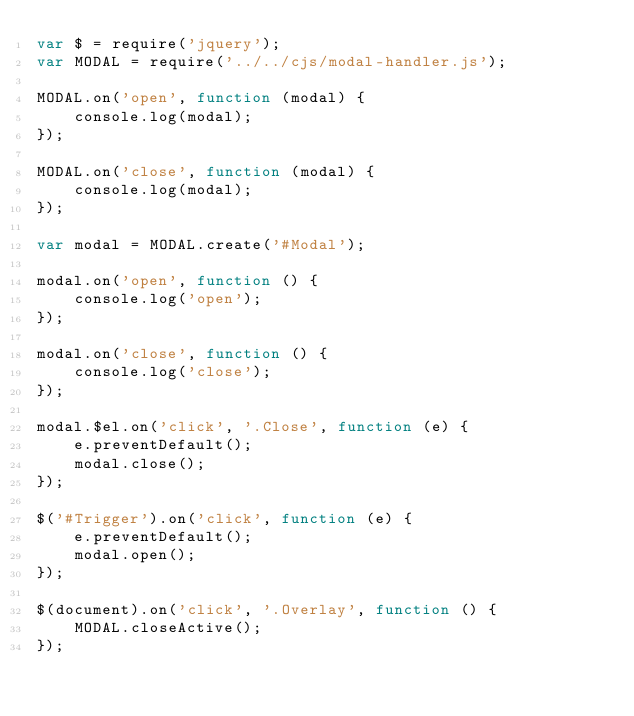<code> <loc_0><loc_0><loc_500><loc_500><_JavaScript_>var $ = require('jquery');
var MODAL = require('../../cjs/modal-handler.js');

MODAL.on('open', function (modal) {
    console.log(modal);
});

MODAL.on('close', function (modal) {
    console.log(modal);
});

var modal = MODAL.create('#Modal');

modal.on('open', function () {
    console.log('open');
});

modal.on('close', function () {
    console.log('close');
});

modal.$el.on('click', '.Close', function (e) {
    e.preventDefault();
    modal.close();
});

$('#Trigger').on('click', function (e) {
    e.preventDefault();
    modal.open();
});

$(document).on('click', '.Overlay', function () {
    MODAL.closeActive();
});
</code> 